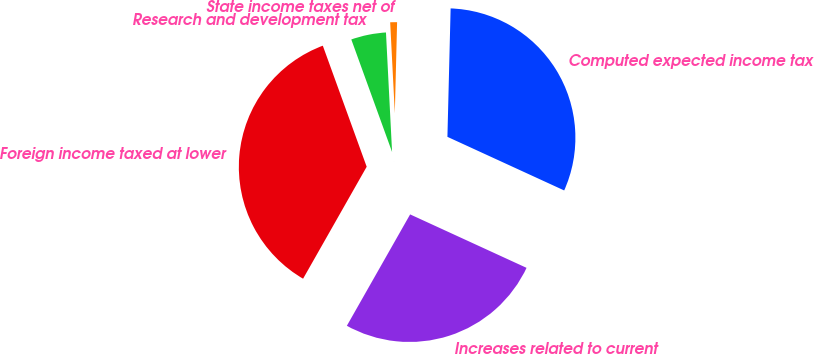Convert chart. <chart><loc_0><loc_0><loc_500><loc_500><pie_chart><fcel>Computed expected income tax<fcel>State income taxes net of<fcel>Research and development tax<fcel>Foreign income taxed at lower<fcel>Increases related to current<nl><fcel>31.45%<fcel>1.21%<fcel>4.72%<fcel>36.24%<fcel>26.37%<nl></chart> 